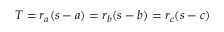<formula> <loc_0><loc_0><loc_500><loc_500>T = r _ { a } ( s - a ) = r _ { b } ( s - b ) = r _ { c } ( s - c )</formula> 